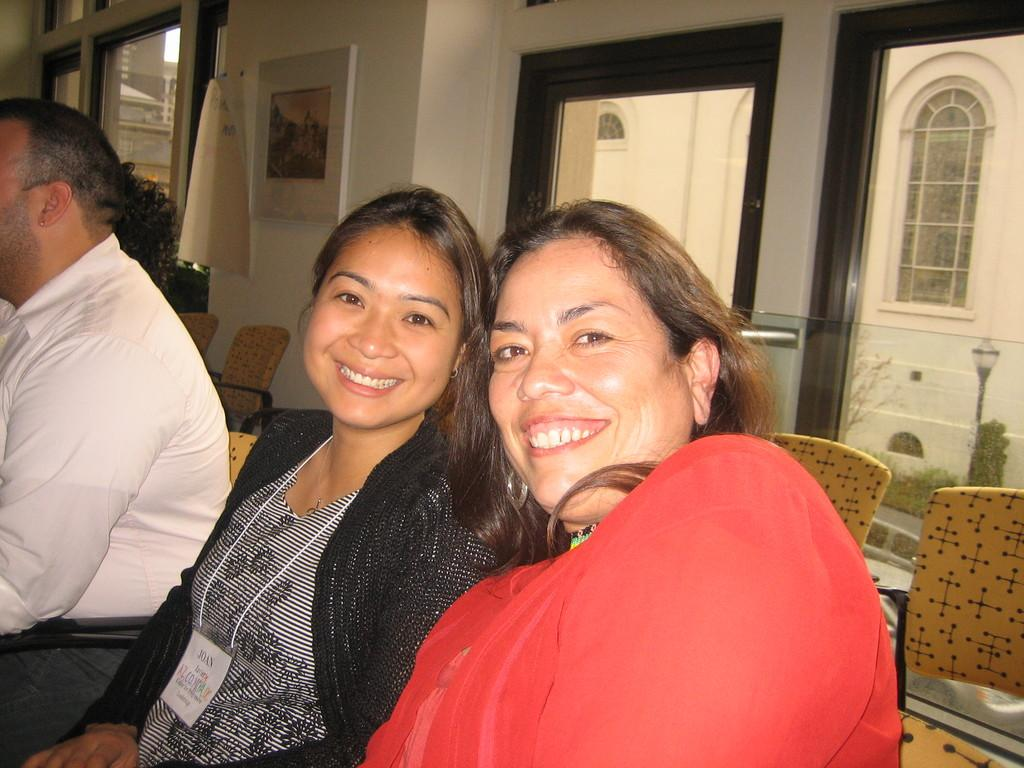How many people are in the image? There are two women and a man in the image. What are the individuals doing in the image? The individuals are sitting on chairs. Can you describe the background of the image? There are chairs and a wall in the background of the image. What is special about the wall in the background? The wall has glass windows and a frame on it. Where is the kitten playing in the image? There is no kitten present in the image. What type of market can be seen in the background of the image? There is no market visible in the image; it features a wall with glass windows and a frame. 